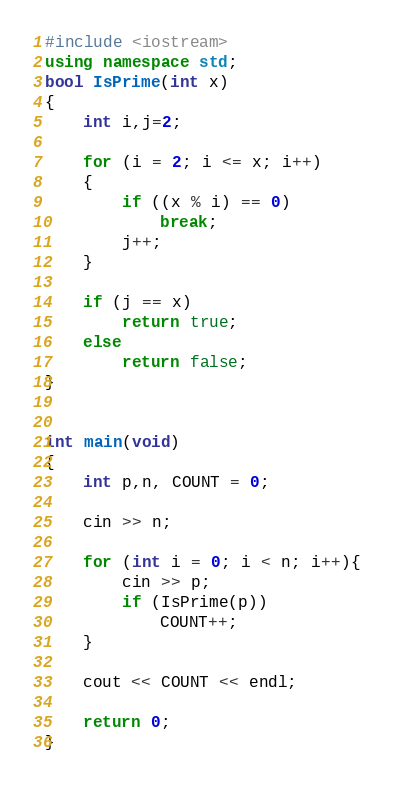<code> <loc_0><loc_0><loc_500><loc_500><_C++_>#include <iostream>
using namespace std;
bool IsPrime(int x)
{
    int i,j=2;

	for (i = 2; i <= x; i++)
	{
		if ((x % i) == 0)
		    break;
		j++;
	}

    if (j == x)
        return true;
    else
        return false;
}


int main(void)
{
	int p,n, COUNT = 0;

	cin >> n;

	for (int i = 0; i < n; i++){
		cin >> p;
		if (IsPrime(p))
			COUNT++;
	}

	cout << COUNT << endl;

	return 0;
}
</code> 